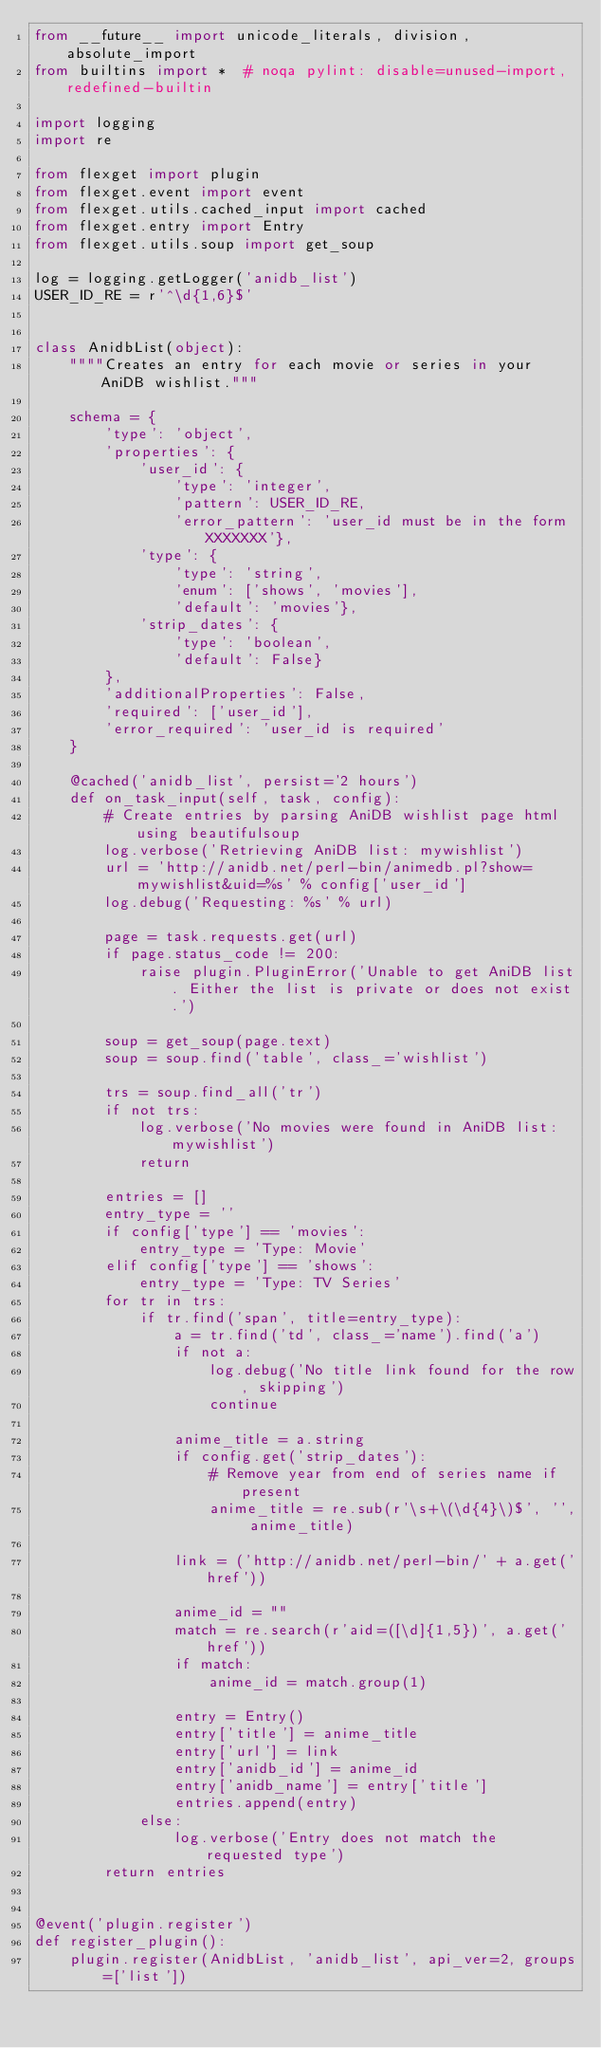<code> <loc_0><loc_0><loc_500><loc_500><_Python_>from __future__ import unicode_literals, division, absolute_import
from builtins import *  # noqa pylint: disable=unused-import, redefined-builtin

import logging
import re

from flexget import plugin
from flexget.event import event
from flexget.utils.cached_input import cached
from flexget.entry import Entry
from flexget.utils.soup import get_soup

log = logging.getLogger('anidb_list')
USER_ID_RE = r'^\d{1,6}$'


class AnidbList(object):
    """"Creates an entry for each movie or series in your AniDB wishlist."""

    schema = {
        'type': 'object',
        'properties': {
            'user_id': {
                'type': 'integer',
                'pattern': USER_ID_RE,
                'error_pattern': 'user_id must be in the form XXXXXXX'},
            'type': {
                'type': 'string',
                'enum': ['shows', 'movies'],
                'default': 'movies'},
            'strip_dates': {
                'type': 'boolean',
                'default': False}
        },
        'additionalProperties': False,
        'required': ['user_id'],
        'error_required': 'user_id is required'
    }

    @cached('anidb_list', persist='2 hours')
    def on_task_input(self, task, config):
        # Create entries by parsing AniDB wishlist page html using beautifulsoup
        log.verbose('Retrieving AniDB list: mywishlist')
        url = 'http://anidb.net/perl-bin/animedb.pl?show=mywishlist&uid=%s' % config['user_id']
        log.debug('Requesting: %s' % url)

        page = task.requests.get(url)
        if page.status_code != 200:
            raise plugin.PluginError('Unable to get AniDB list. Either the list is private or does not exist.')

        soup = get_soup(page.text)
        soup = soup.find('table', class_='wishlist')

        trs = soup.find_all('tr')
        if not trs:
            log.verbose('No movies were found in AniDB list: mywishlist')
            return

        entries = []
        entry_type = ''
        if config['type'] == 'movies':
            entry_type = 'Type: Movie'
        elif config['type'] == 'shows':
            entry_type = 'Type: TV Series'
        for tr in trs:
            if tr.find('span', title=entry_type):
                a = tr.find('td', class_='name').find('a')
                if not a:
                    log.debug('No title link found for the row, skipping')
                    continue

                anime_title = a.string
                if config.get('strip_dates'):
                    # Remove year from end of series name if present
                    anime_title = re.sub(r'\s+\(\d{4}\)$', '', anime_title)

                link = ('http://anidb.net/perl-bin/' + a.get('href'))

                anime_id = ""
                match = re.search(r'aid=([\d]{1,5})', a.get('href'))
                if match:
                    anime_id = match.group(1)

                entry = Entry()
                entry['title'] = anime_title
                entry['url'] = link
                entry['anidb_id'] = anime_id
                entry['anidb_name'] = entry['title']
                entries.append(entry)
            else:
                log.verbose('Entry does not match the requested type')
        return entries


@event('plugin.register')
def register_plugin():
    plugin.register(AnidbList, 'anidb_list', api_ver=2, groups=['list'])
</code> 